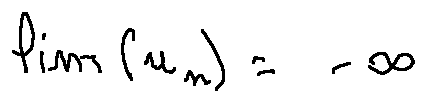<formula> <loc_0><loc_0><loc_500><loc_500>\lim ( u _ { n } ) = - \infty</formula> 